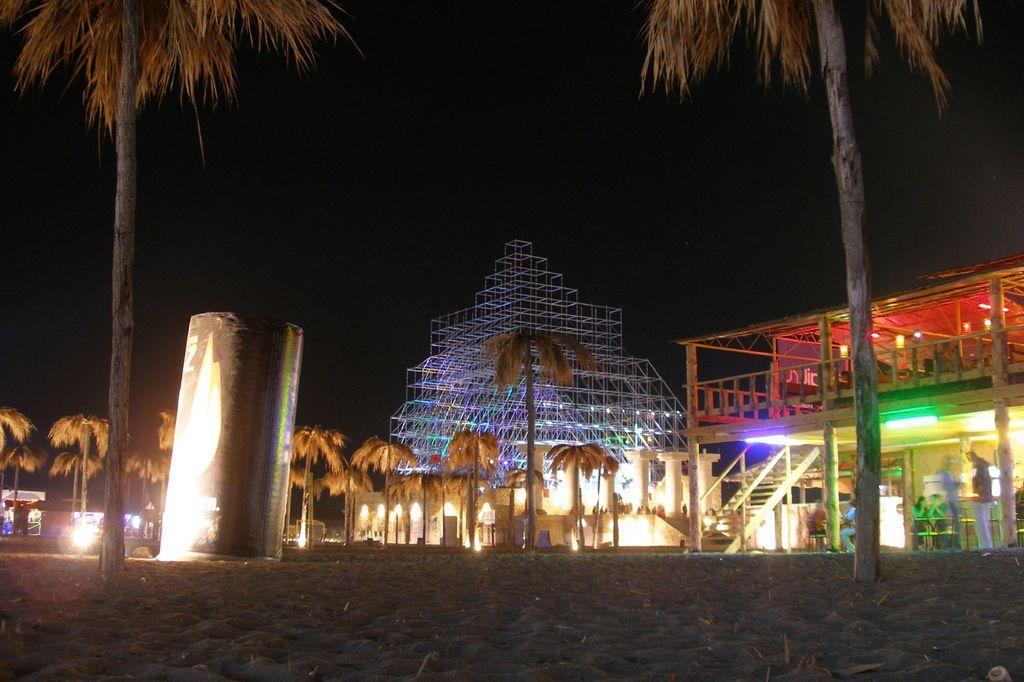Could you give a brief overview of what you see in this image? In this image I can see many trees and an object. To the right I can see the shed, the structure which is made up of metal rods and the lights. I can see the black background. 